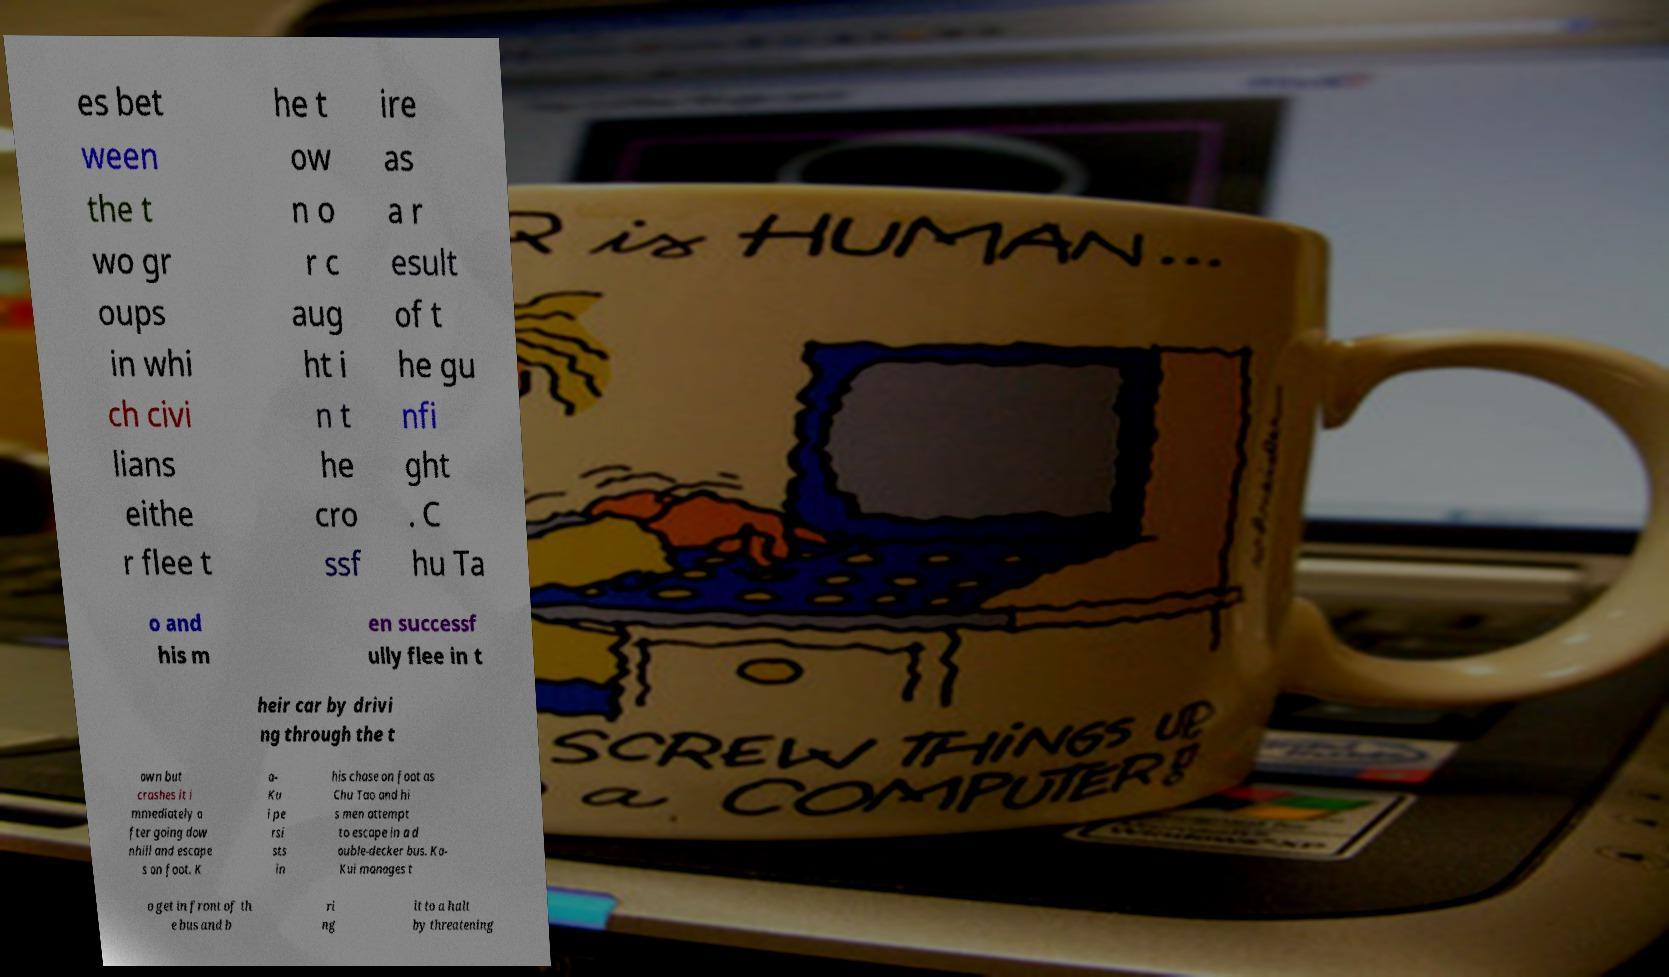There's text embedded in this image that I need extracted. Can you transcribe it verbatim? es bet ween the t wo gr oups in whi ch civi lians eithe r flee t he t ow n o r c aug ht i n t he cro ssf ire as a r esult of t he gu nfi ght . C hu Ta o and his m en successf ully flee in t heir car by drivi ng through the t own but crashes it i mmediately a fter going dow nhill and escape s on foot. K a- Ku i pe rsi sts in his chase on foot as Chu Tao and hi s men attempt to escape in a d ouble-decker bus. Ka- Kui manages t o get in front of th e bus and b ri ng it to a halt by threatening 